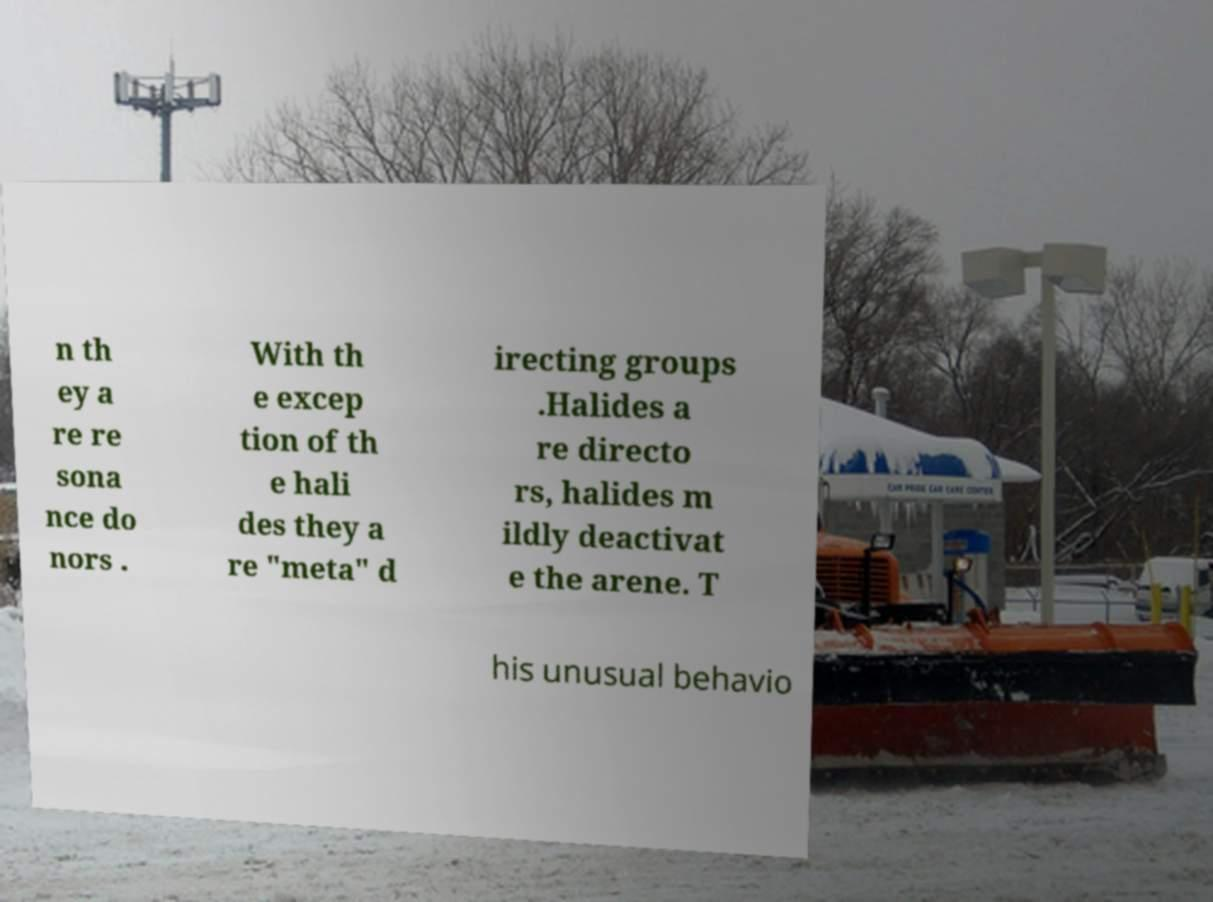For documentation purposes, I need the text within this image transcribed. Could you provide that? n th ey a re re sona nce do nors . With th e excep tion of th e hali des they a re "meta" d irecting groups .Halides a re directo rs, halides m ildly deactivat e the arene. T his unusual behavio 